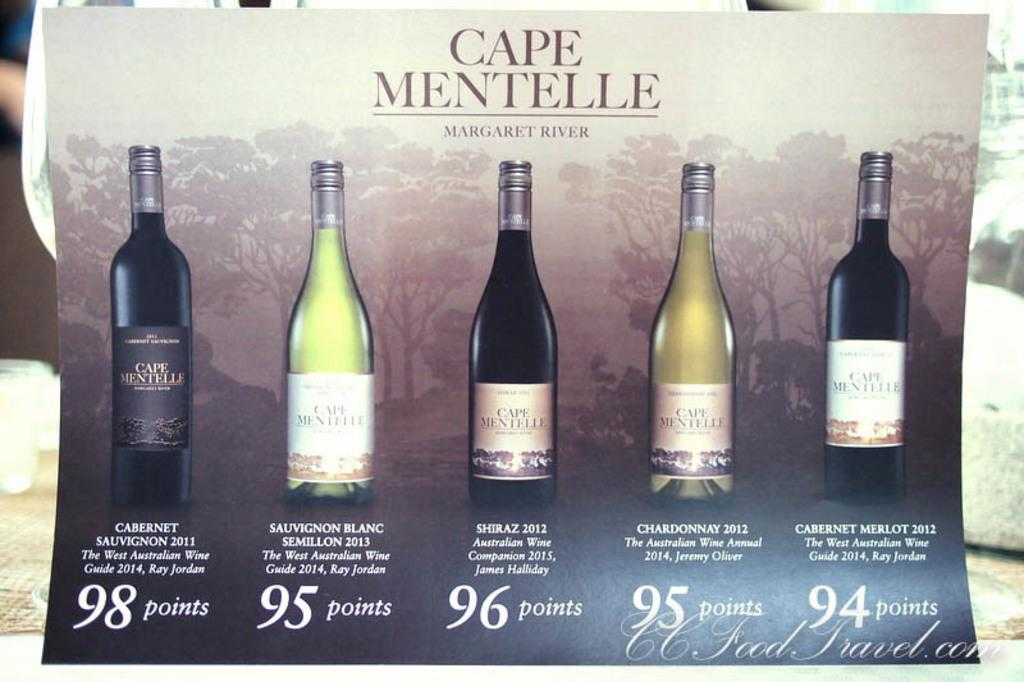<image>
Write a terse but informative summary of the picture. Poster for alcohol bottles with one bottle that is 98 points. 